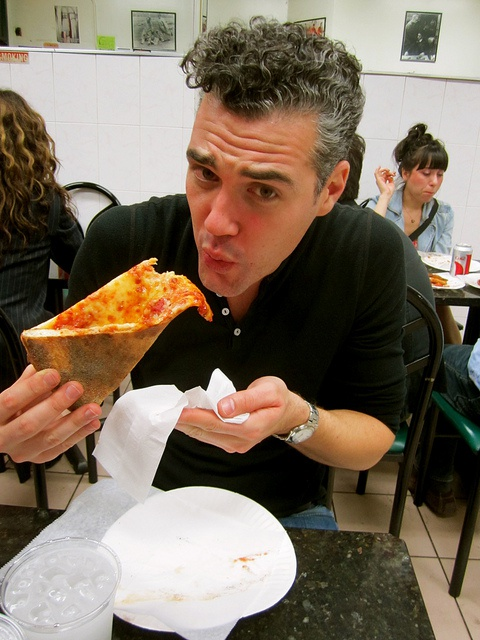Describe the objects in this image and their specific colors. I can see people in black, brown, salmon, and tan tones, dining table in black, lightgray, darkgray, and darkgreen tones, people in black, maroon, olive, and lightgray tones, pizza in black, brown, orange, red, and maroon tones, and cup in black, lightgray, and darkgray tones in this image. 